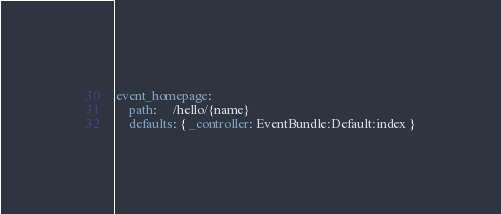Convert code to text. <code><loc_0><loc_0><loc_500><loc_500><_YAML_>event_homepage:
    path:     /hello/{name}
    defaults: { _controller: EventBundle:Default:index }
</code> 